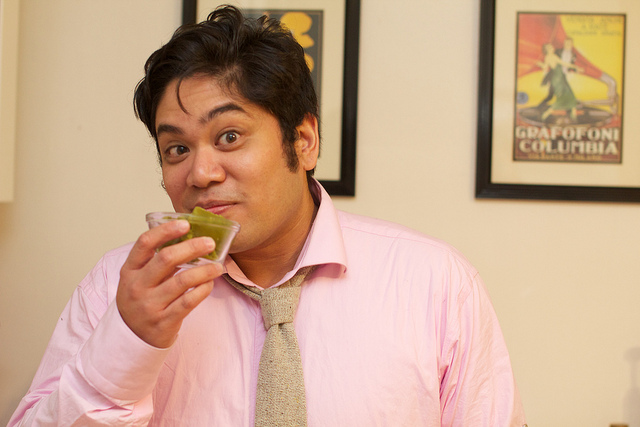<image>What food is he eating? It is unknown what food he is eating. It could be a sandwich, grapes, salad or even jello. What food is he eating? I don't know what food he is eating. It can be sandwich, grapes, salad, tea, jello, pickle, soup, or fruit. 